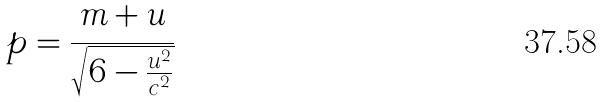Convert formula to latex. <formula><loc_0><loc_0><loc_500><loc_500>p = \frac { m + u } { \sqrt { 6 - \frac { u ^ { 2 } } { c ^ { 2 } } } }</formula> 